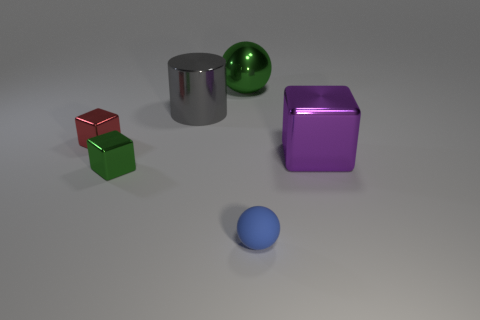Subtract all large metallic cubes. How many cubes are left? 2 Add 3 tiny green metallic spheres. How many objects exist? 9 Subtract 1 cubes. How many cubes are left? 2 Subtract all cylinders. How many objects are left? 5 Subtract all blue balls. How many balls are left? 1 Add 2 big rubber cubes. How many big rubber cubes exist? 2 Subtract 0 red cylinders. How many objects are left? 6 Subtract all purple blocks. Subtract all purple balls. How many blocks are left? 2 Subtract all tiny gray metal cylinders. Subtract all gray objects. How many objects are left? 5 Add 6 tiny shiny cubes. How many tiny shiny cubes are left? 8 